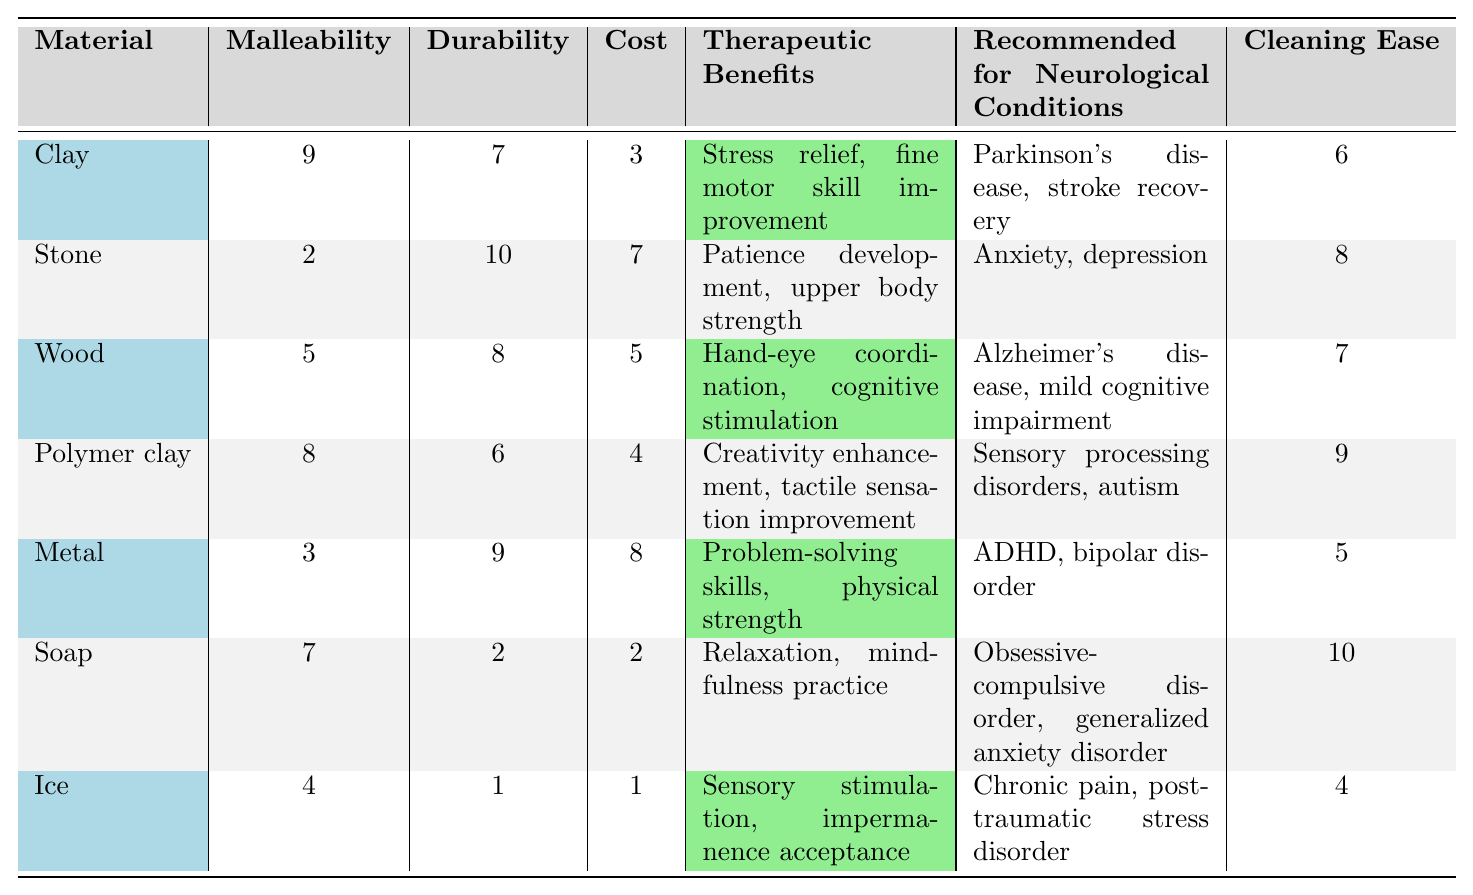What is the therapeutic benefit of using metal as a sculpting material? The column for therapeutic benefits shows that metal is associated with "Problem-solving skills, physical strength."
Answer: Problem-solving skills, physical strength Which material has the highest cost? By comparing the values in the cost column, metal has the highest value of 8.
Answer: Metal Is soap easy to clean compared to ice? The cleaning ease value for soap is 10, and for ice, it is 4, indicating that soap is easier to clean.
Answer: Yes What is the average malleability score of the materials? The malleability scores are 9, 2, 5, 8, 3, 7, and 4. Adding them gives 38, and there are 7 materials, so the average is 38/7 ≈ 5.43.
Answer: Approximately 5.43 Which material is recommended for stroke recovery? The table shows that clay is recommended for "Parkinson's disease, stroke recovery."
Answer: Clay What is the difference in durability between stone and polymer clay? The durability for stone is 10 and for polymer clay is 6. The difference is 10 - 6 = 4.
Answer: 4 Are the therapeutic benefits of clay and wood the same? Clay offers "Stress relief, fine motor skill improvement," while wood offers "Hand-eye coordination, cognitive stimulation," indicating they are different.
Answer: No Which two materials are recommended for conditions involving anxiety? Stone is recommended for anxiety and soap is recommended for generalized anxiety disorder.
Answer: Stone and soap What is the highest durability score among the materials? The maximum value in the durability column is 10, which corresponds to stone.
Answer: Stone How many materials are recommended for conditions related to cognitive impairment? The materials listed for cognitive impairment are wood (Alzheimer's disease, mild cognitive impairment) and polymer clay (sensory processing disorders, autism). Therefore, there are two materials recommended.
Answer: 2 